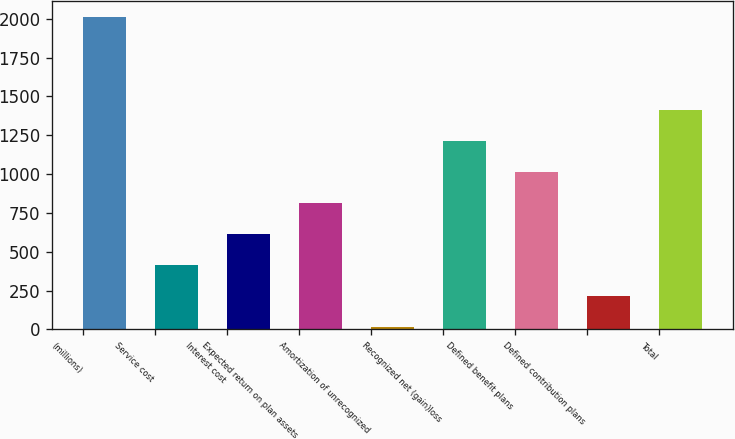Convert chart to OTSL. <chart><loc_0><loc_0><loc_500><loc_500><bar_chart><fcel>(millions)<fcel>Service cost<fcel>Interest cost<fcel>Expected return on plan assets<fcel>Amortization of unrecognized<fcel>Recognized net (gain)loss<fcel>Defined benefit plans<fcel>Defined contribution plans<fcel>Total<nl><fcel>2012<fcel>413.6<fcel>613.4<fcel>813.2<fcel>14<fcel>1212.8<fcel>1013<fcel>213.8<fcel>1412.6<nl></chart> 